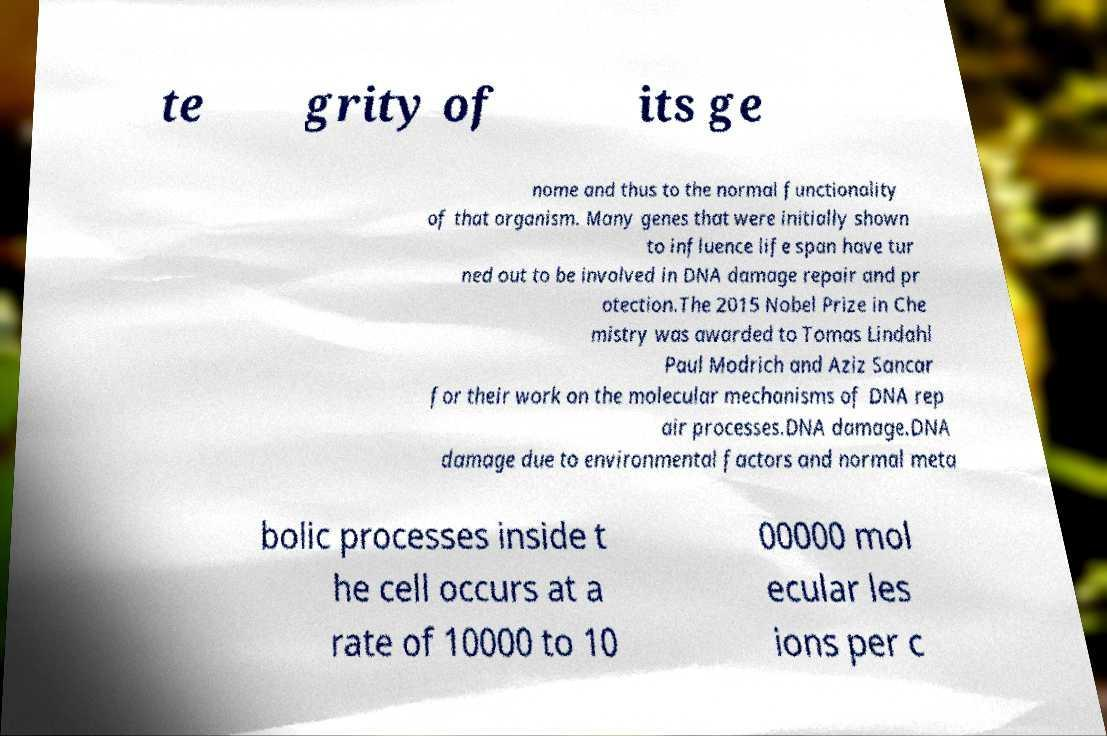There's text embedded in this image that I need extracted. Can you transcribe it verbatim? te grity of its ge nome and thus to the normal functionality of that organism. Many genes that were initially shown to influence life span have tur ned out to be involved in DNA damage repair and pr otection.The 2015 Nobel Prize in Che mistry was awarded to Tomas Lindahl Paul Modrich and Aziz Sancar for their work on the molecular mechanisms of DNA rep air processes.DNA damage.DNA damage due to environmental factors and normal meta bolic processes inside t he cell occurs at a rate of 10000 to 10 00000 mol ecular les ions per c 